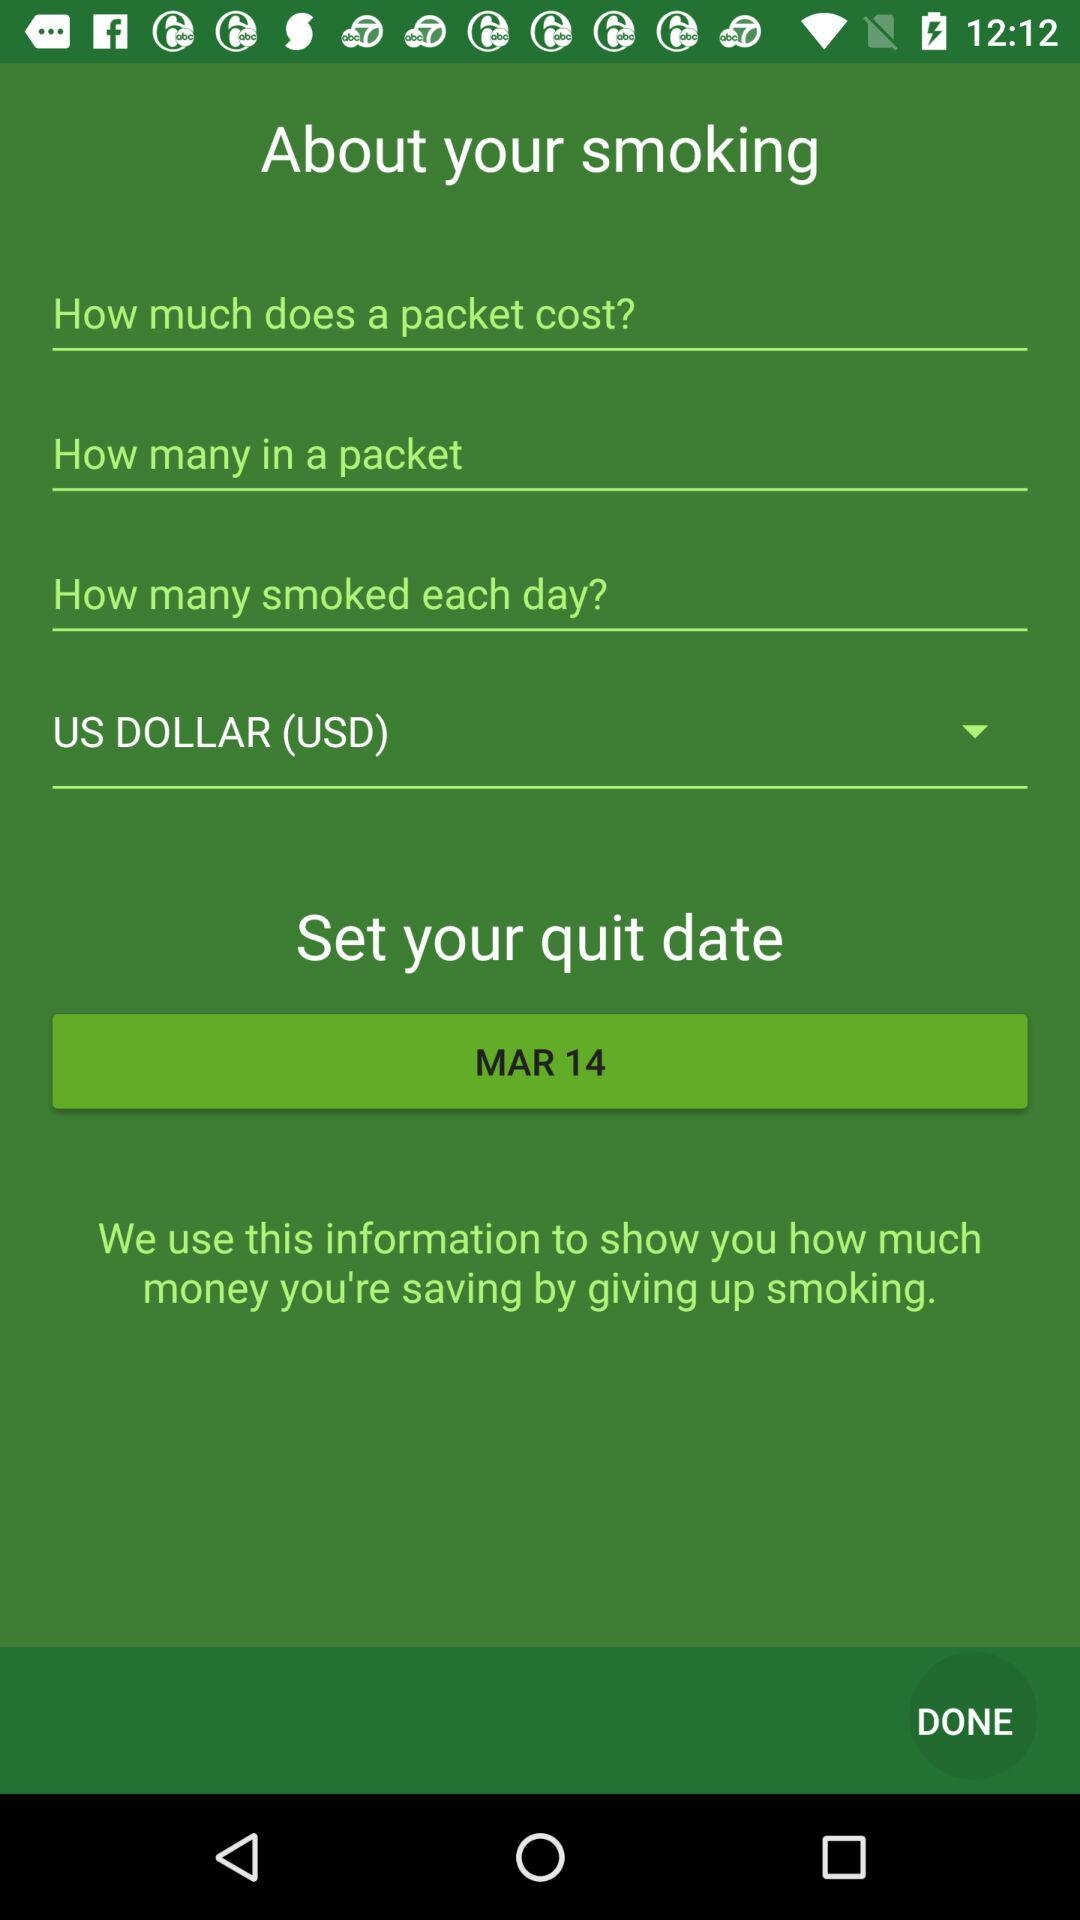Which date is selected? The selected date is March 14. 